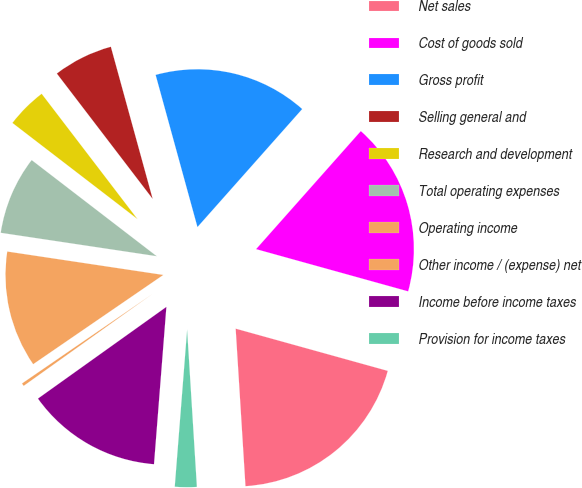Convert chart to OTSL. <chart><loc_0><loc_0><loc_500><loc_500><pie_chart><fcel>Net sales<fcel>Cost of goods sold<fcel>Gross profit<fcel>Selling general and<fcel>Research and development<fcel>Total operating expenses<fcel>Operating income<fcel>Other income / (expense) net<fcel>Income before income taxes<fcel>Provision for income taxes<nl><fcel>19.7%<fcel>17.76%<fcel>15.82%<fcel>6.12%<fcel>4.18%<fcel>8.06%<fcel>11.94%<fcel>0.3%<fcel>13.88%<fcel>2.24%<nl></chart> 